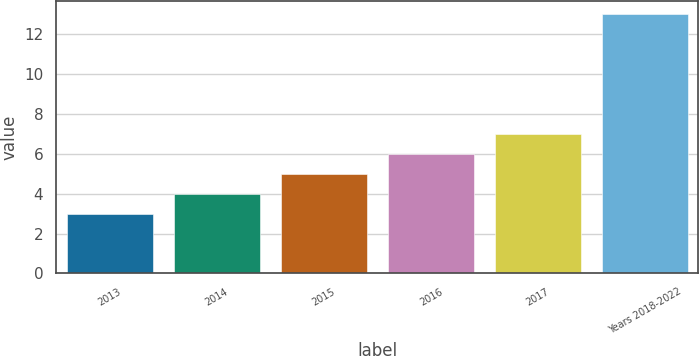<chart> <loc_0><loc_0><loc_500><loc_500><bar_chart><fcel>2013<fcel>2014<fcel>2015<fcel>2016<fcel>2017<fcel>Years 2018-2022<nl><fcel>3<fcel>4<fcel>5<fcel>6<fcel>7<fcel>13<nl></chart> 